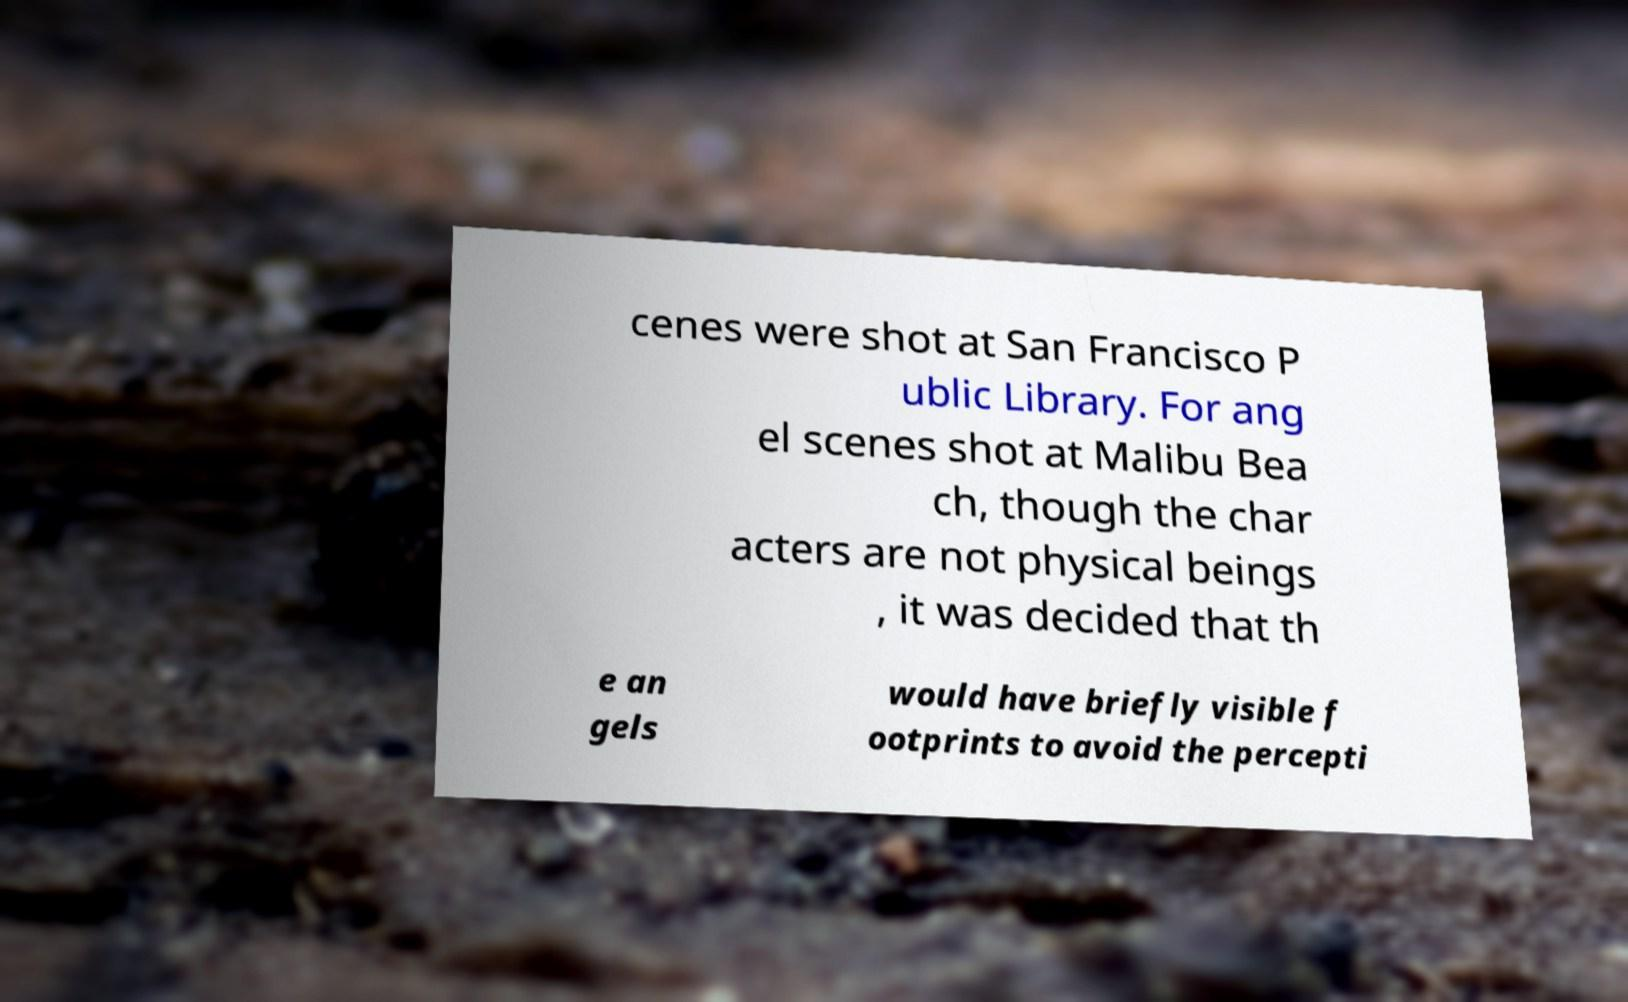Could you assist in decoding the text presented in this image and type it out clearly? cenes were shot at San Francisco P ublic Library. For ang el scenes shot at Malibu Bea ch, though the char acters are not physical beings , it was decided that th e an gels would have briefly visible f ootprints to avoid the percepti 